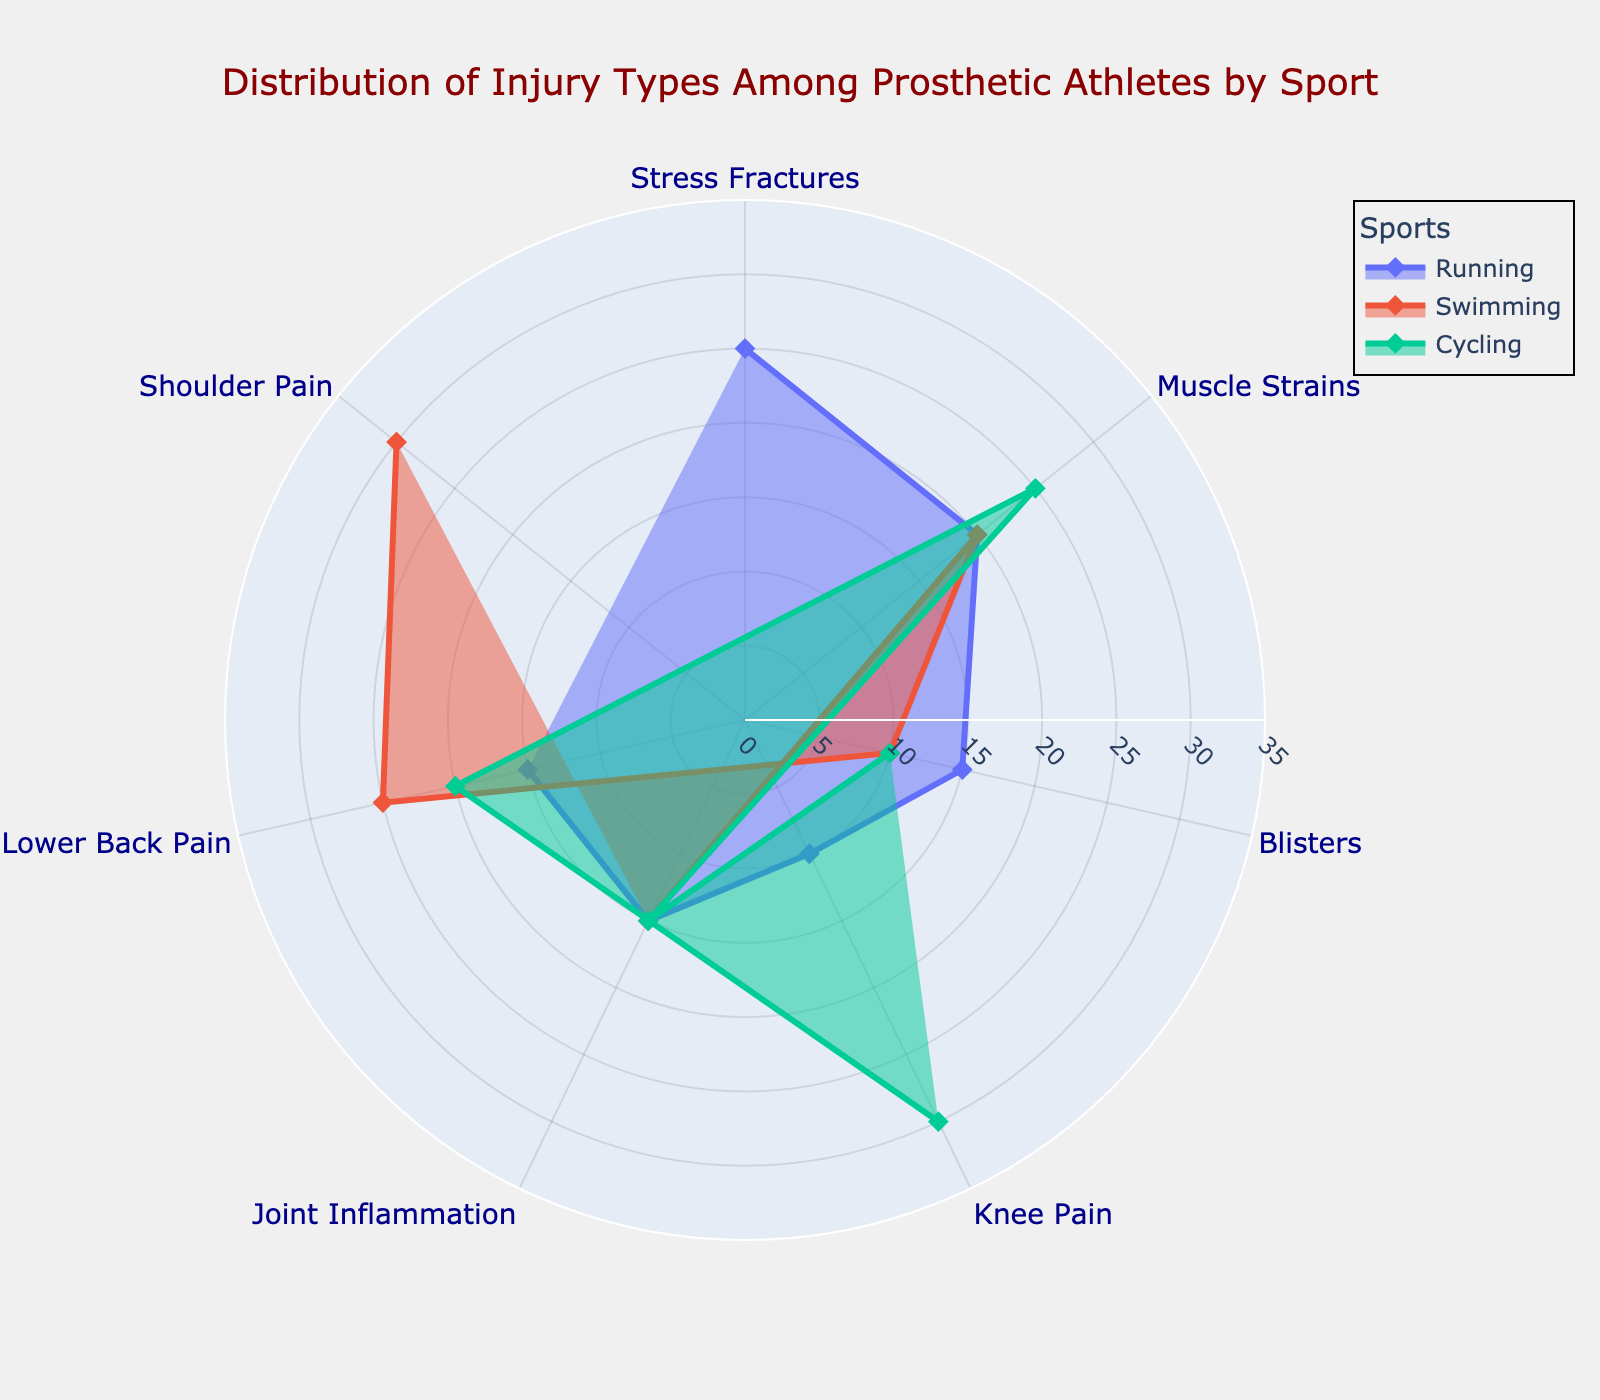What's the title of the chart? The title is typically located at the top of the figure. From the information given, we know the title is "Distribution of Injury Types Among Prosthetic Athletes by Sport".
Answer: Distribution of Injury Types Among Prosthetic Athletes by Sport Which sport has the highest percentage of shoulder pain injuries? To determine this, locate the segment labeled "Shoulder Pain" and observe which sport has the highest radial length. According to the data, Swimming shows the highest percentage for shoulder pain at 30%.
Answer: Swimming How many types of injuries are depicted in the chart? Count the unique labels around the polar chart. The provided data lists "Stress Fractures," "Muscle Strains," "Blisters," "Knee Pain," "Joint Inflammation," "Lower Back Pain," "Shoulder Pain".
Answer: 7 Which injury is the most common in running? For this, identify the injury type with the largest percentage in the running segment. The data shows "Stress Fractures" at 25%, which is the highest for running.
Answer: Stress Fractures What is the combined percentage of lower back pain injuries in Swimming and Cycling? Add the percentages for lower back pain in both sports. Swimming has 25% and Cycling has 20%. So, 25 + 20 = 45%.
Answer: 45% Which sport has the smallest percentage of blisters-related injuries? Compare the percentages of blisters for Running, Swimming, and Cycling. Running has 15%, Swimming has 10%, and Cycling has 10%. The smallest, which is 10%, is found in both Swimming and Cycling.
Answer: Swimming, Cycling What percentage of injuries in cycling are muscle strains? Identify the percentage value corresponding to muscle strains under cycling in the chart. According to the data, muscle strains account for 25% of injuries in cycling.
Answer: 25% Which injury type has the highest variability in percentages among the three sports? To determine variability, compare the spread of values for each injury type across Running, Swimming, and Cycling. "Blisters" range from 10% to 15%, "Muscle Strains" from 20% to 25%, "Lower Back Pain" from 10% to 25%, etc. The injury type with the highest variability is "Lower Back Pain," spanning from 10% to 25%.
Answer: Lower Back Pain 